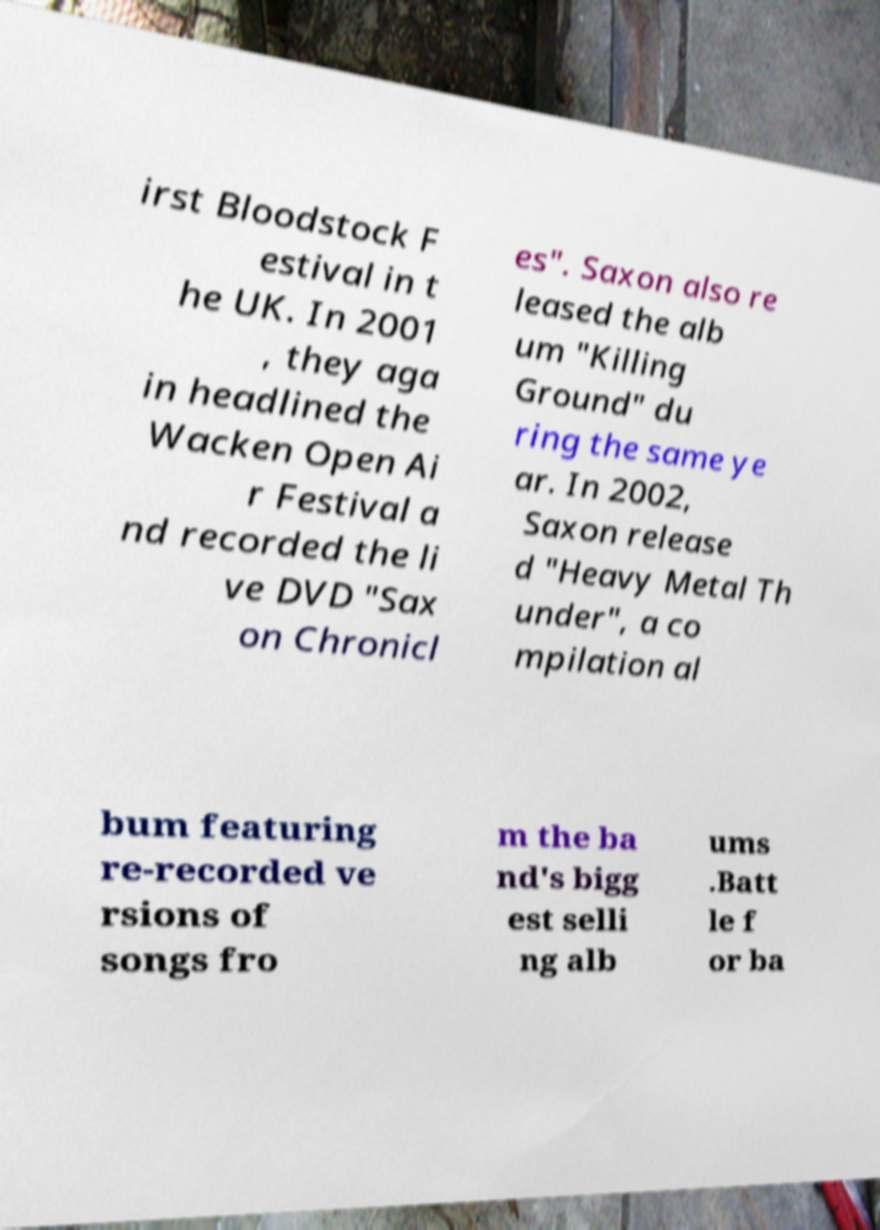Please identify and transcribe the text found in this image. irst Bloodstock F estival in t he UK. In 2001 , they aga in headlined the Wacken Open Ai r Festival a nd recorded the li ve DVD "Sax on Chronicl es". Saxon also re leased the alb um "Killing Ground" du ring the same ye ar. In 2002, Saxon release d "Heavy Metal Th under", a co mpilation al bum featuring re-recorded ve rsions of songs fro m the ba nd's bigg est selli ng alb ums .Batt le f or ba 